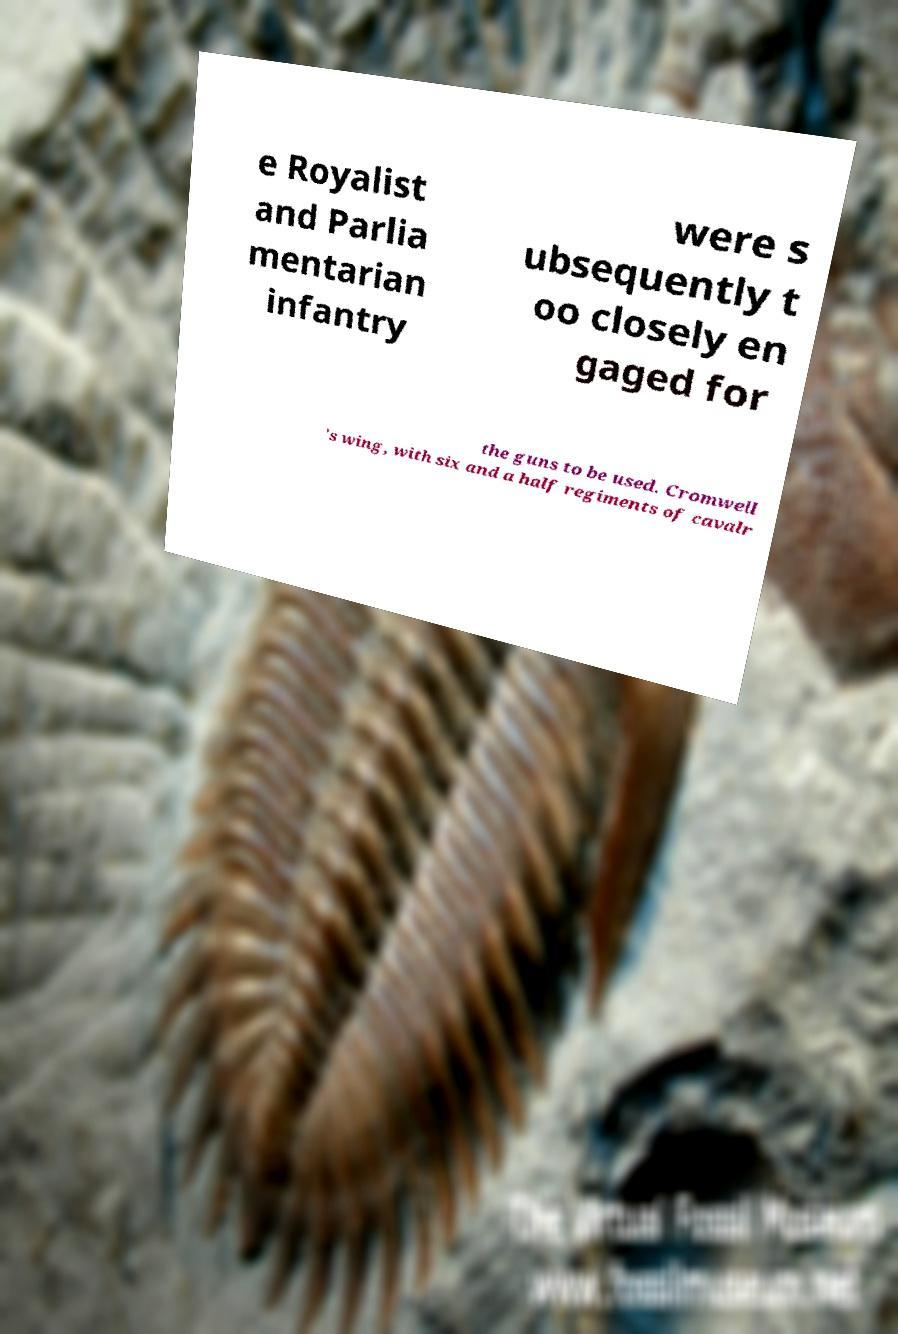Could you extract and type out the text from this image? e Royalist and Parlia mentarian infantry were s ubsequently t oo closely en gaged for the guns to be used. Cromwell 's wing, with six and a half regiments of cavalr 